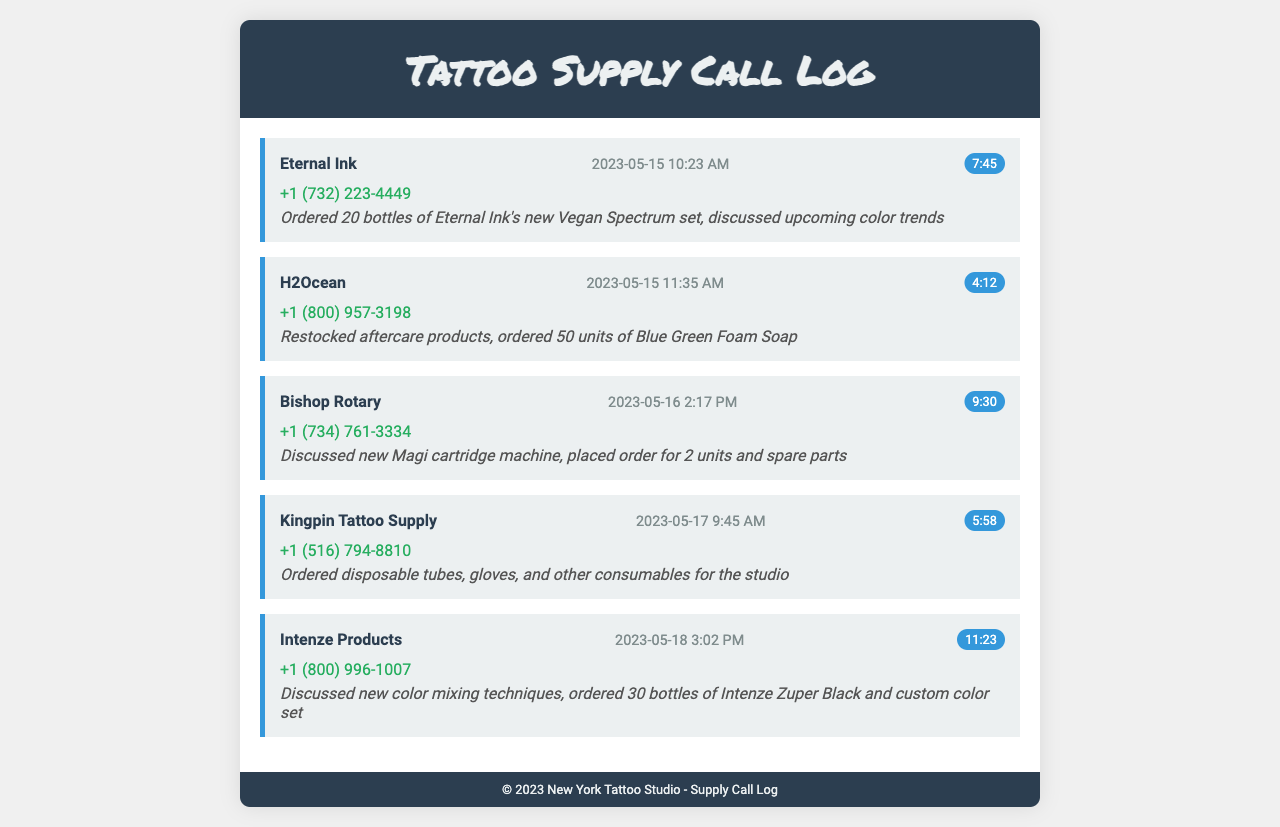What is the name of the first vendor? The first vendor listed in the call log is Eternal Ink.
Answer: Eternal Ink On what date was the call to H2Ocean made? The call to H2Ocean was made on May 15, 2023.
Answer: May 15, 2023 How long did the call to Bishop Rotary last? The duration of the call to Bishop Rotary was 9 minutes and 30 seconds.
Answer: 9:30 What was ordered from Kingpin Tattoo Supply? The supplies ordered from Kingpin Tattoo Supply included disposable tubes, gloves, and other consumables.
Answer: Disposable tubes, gloves, and other consumables How many bottles of the custom color set were ordered from Intenze Products? The order from Intenze Products included 30 bottles of Intenze Zuper Black and a custom color set.
Answer: 30 bottles Which vendor was discussed regarding new color mixing techniques? The vendor that was discussed regarding new color mixing techniques is Intenze Products.
Answer: Intenze Products What type of machine was discussed during the call to Bishop Rotary? The call to Bishop Rotary included a discussion about the new Magi cartridge machine.
Answer: Magi cartridge machine How many units of Blue Green Foam Soap were ordered from H2Ocean? There were 50 units of Blue Green Foam Soap ordered from H2Ocean.
Answer: 50 units 